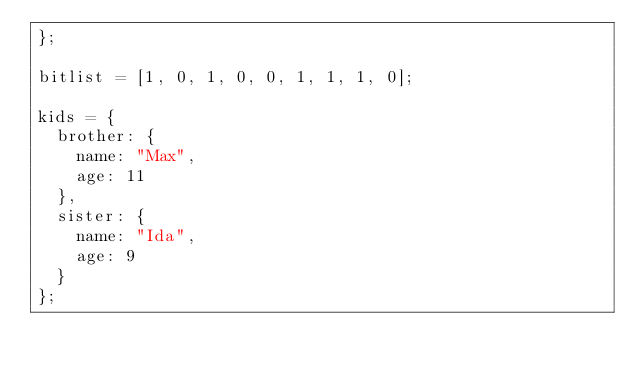Convert code to text. <code><loc_0><loc_0><loc_500><loc_500><_JavaScript_>};

bitlist = [1, 0, 1, 0, 0, 1, 1, 1, 0];

kids = {
  brother: {
    name: "Max",
    age: 11
  },
  sister: {
    name: "Ida",
    age: 9
  }
};
</code> 